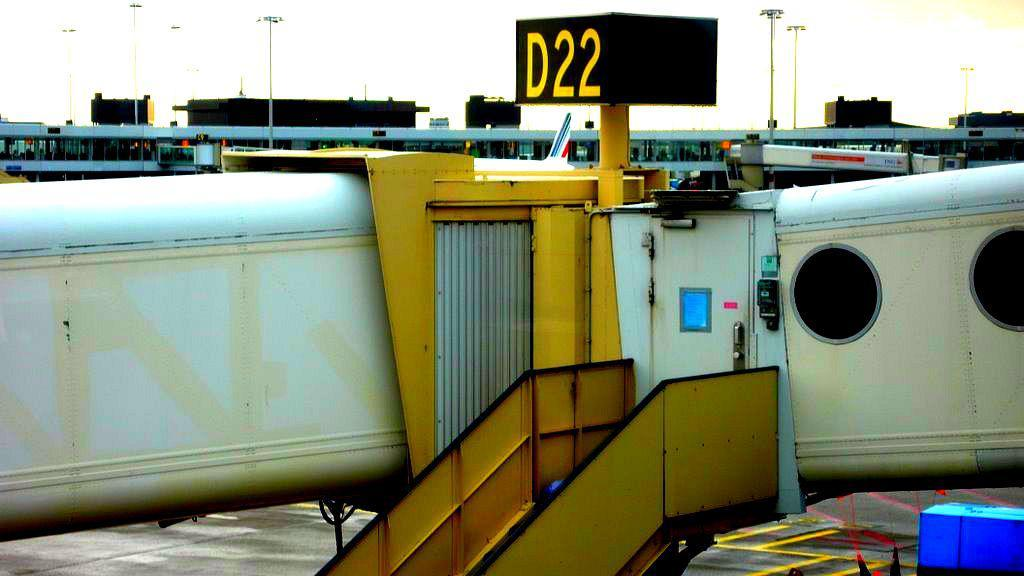<image>
Render a clear and concise summary of the photo. An airport jetway has a big sign that says D22 on top of it. 